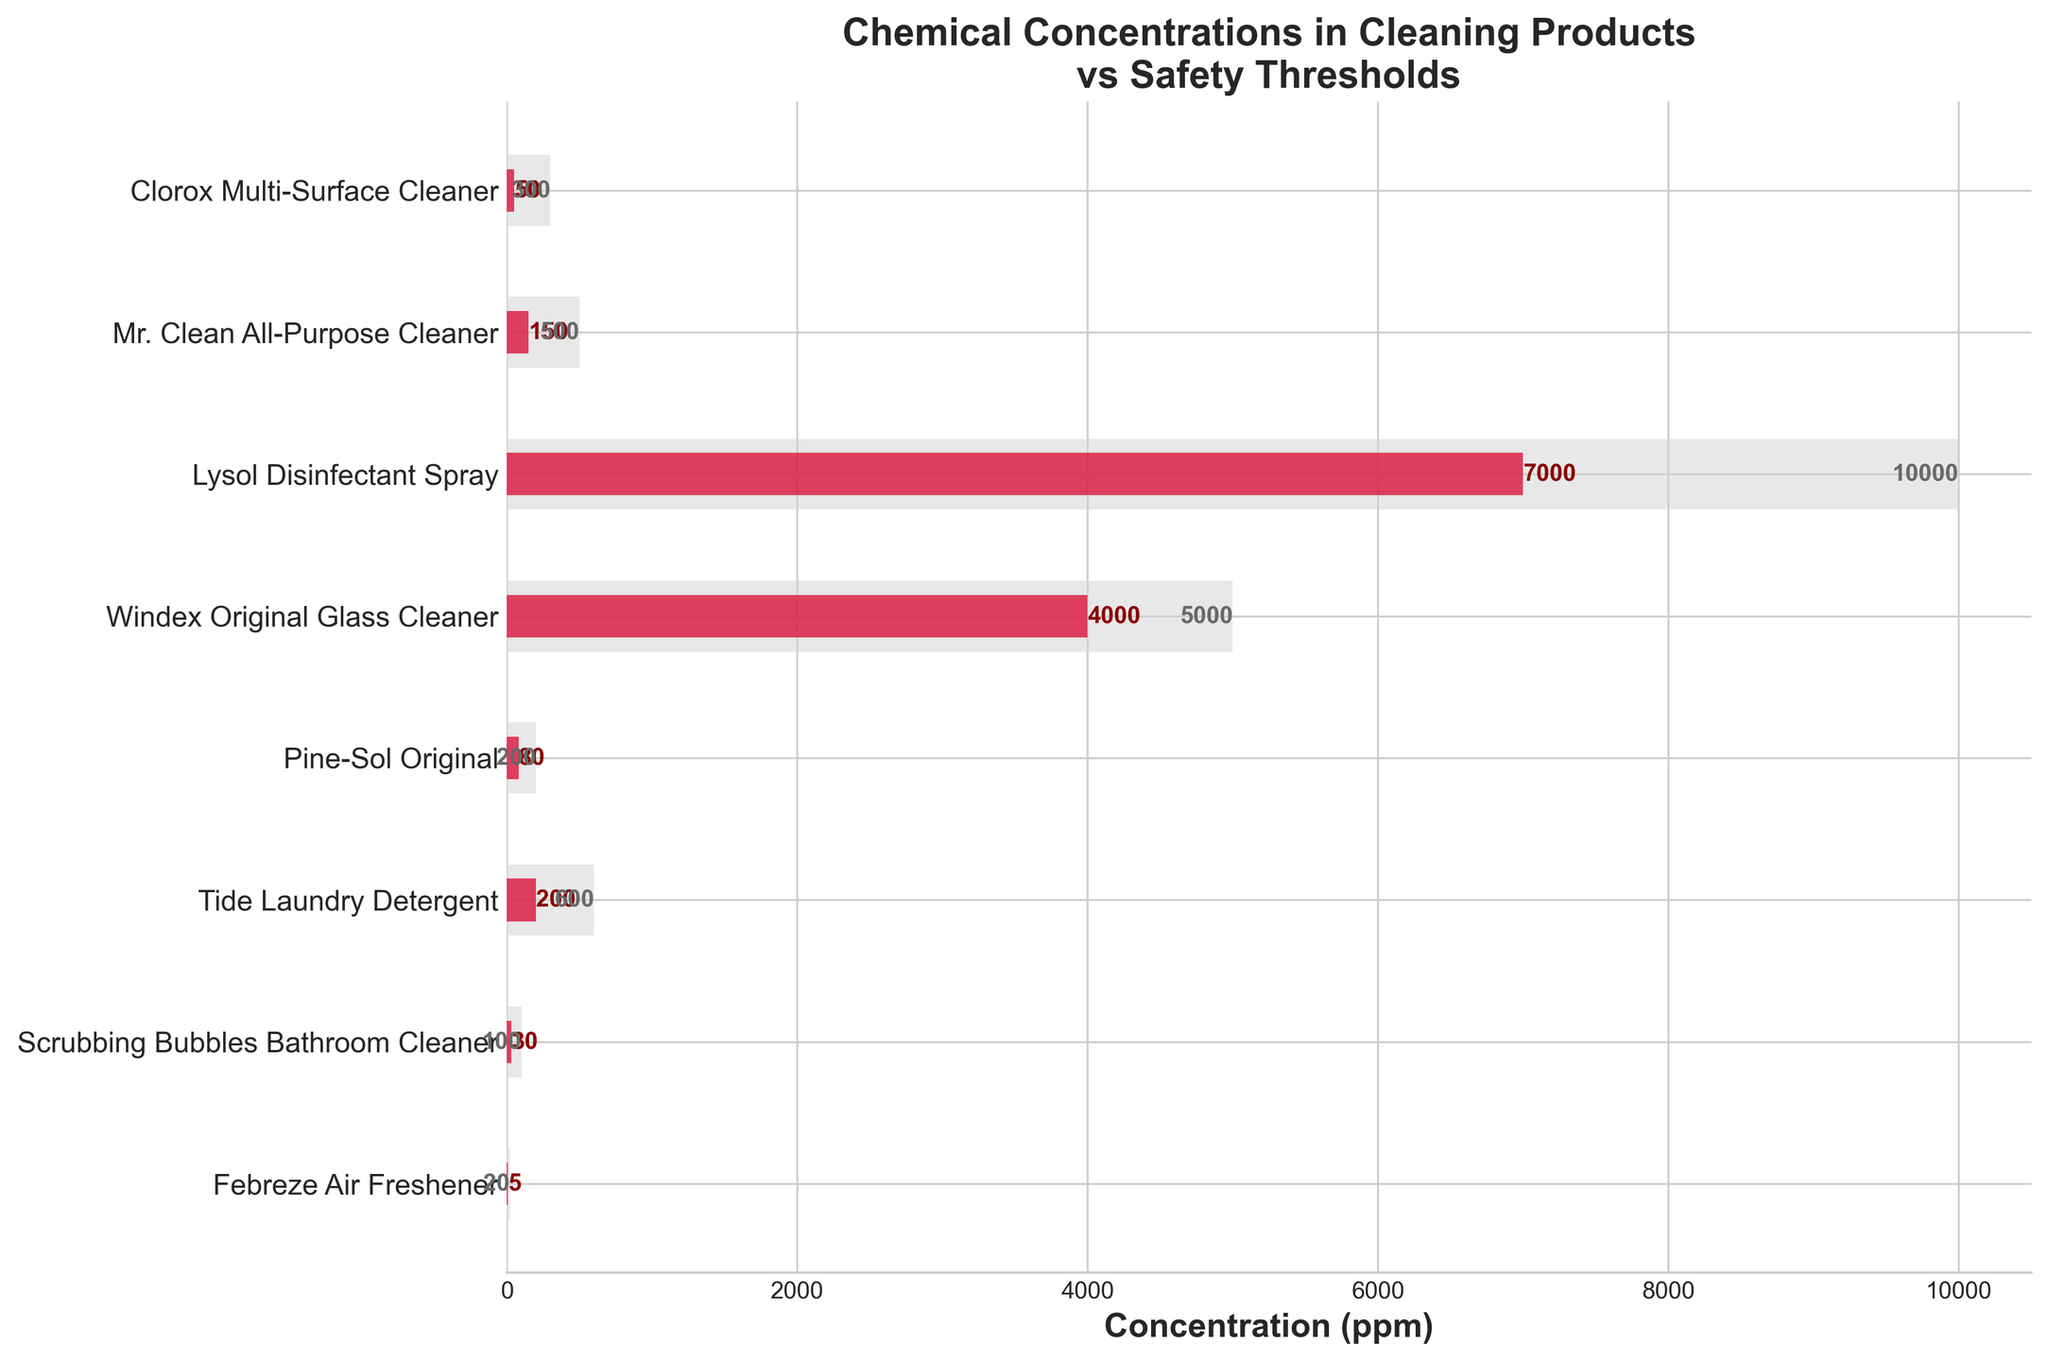What's the title of the figure? The title is typically at the top of the figure and it's meant to summarize the information displayed. Here, it says "Chemical Concentrations in Cleaning Products vs Safety Thresholds".
Answer: Chemical Concentrations in Cleaning Products vs Safety Thresholds Which product has the lowest concentration of chemicals? To find this, look at the shortest red bar in the figure. It corresponds to Febreze Air Freshener, which lists Benzisothiazolinone at 5 ppm.
Answer: Febreze Air Freshener What is the concentration of Isopropyl alcohol in Windex Original Glass Cleaner? Locate the bar labeled "Windex Original Glass Cleaner" and check the red bar's value. It shows 4000 ppm for Isopropyl alcohol.
Answer: 4000 ppm How many products have a chemical concentration below their safety threshold? Compare the red bars (concentration) with the gray bars (safety thresholds) to see which red bars are shorter. This includes all products listed since all red bars are below the respective grey bars.
Answer: 8 Which product has the highest safety threshold, and what is the value? The highest safety threshold corresponds to the longest gray bar, which belongs to Lysol Disinfectant Spray with Ethanol, at 10000 ppm.
Answer: Lysol Disinfectant Spray, 10000 ppm What's the difference between the threshold and concentration for Pine-Sol Original? Identifying values for Pine oil in Pine-Sol Original reveals the threshold is 200 ppm and the concentration is 80 ppm. The difference is found by subtracting concentration from the threshold: 200 - 80 = 120.
Answer: 120 ppm Which products contain less than 100 ppm of their respective chemicals? Check the red bars (concentrations) for values below 100 ppm. This applies to Clorox Multi-Surface Cleaner (50 ppm), Pine-Sol Original (80 ppm), Scrubbing Bubbles Bathroom Cleaner (30 ppm), and Febreze Air Freshener (5 ppm).
Answer: Clorox Multi-Surface Cleaner, Pine-Sol Original, Scrubbing Bubbles Bathroom Cleaner, Febreze Air Freshener How much more concentrated is Isopropyl alcohol in Windex Original Glass Cleaner compared to Benzisothiazolinone in Febreze Air Freshener? The concentration of Isopropyl alcohol in Windex Original Glass Cleaner is 4000 ppm, and Benzisothiazolinone in Febreze Air Freshener is 5 ppm. The difference is 4000 - 5 = 3995 ppm.
Answer: 3995 ppm 